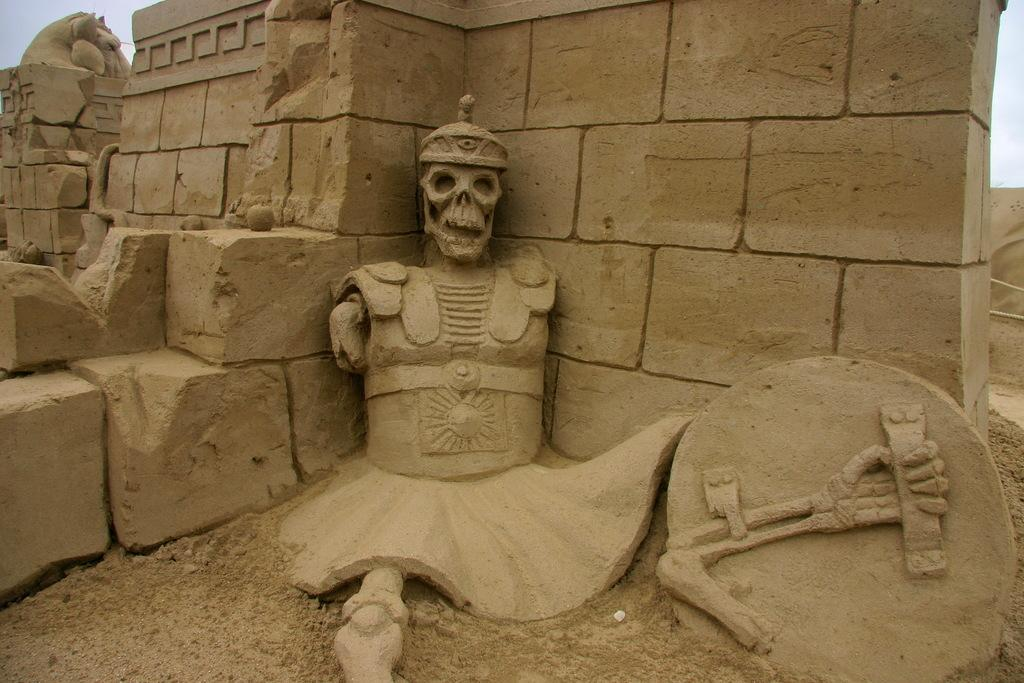What type of art is present in the image? There are sculptures in the image. What is the background of the sculptures in the image? There is a wall in the image. What can be seen above the wall in the image? The sky is visible in the image. What type of tin can be seen in the image? There is no tin present in the image. What attraction is depicted in the image? The image does not depict any specific attraction; it simply shows sculptures, a wall, and the sky. 